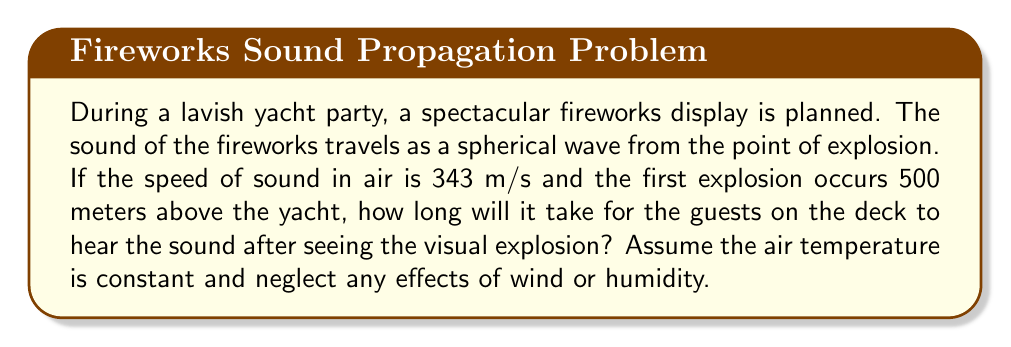What is the answer to this math problem? To solve this problem, we'll use the wave equation in its simplest form for a uniform medium:

$$\frac{\partial^2 u}{\partial t^2} = c^2 \nabla^2 u$$

Where $c$ is the speed of sound in air.

For our case, we're interested in the time it takes for the sound to travel a certain distance. We can use the relationship:

$$\text{Distance} = \text{Speed} \times \text{Time}$$

Or in equation form:
$$d = ct$$

Where:
$d$ = distance traveled by the sound wave
$c$ = speed of sound in air
$t$ = time taken

We're given:
$c = 343$ m/s
$d = 500$ m (straight-line distance from explosion to yacht)

Rearranging the equation to solve for time:

$$t = \frac{d}{c}$$

Substituting our values:

$$t = \frac{500 \text{ m}}{343 \text{ m/s}}$$

$$t \approx 1.4577 \text{ seconds}$$

Therefore, the guests will hear the sound of the fireworks approximately 1.46 seconds after seeing the visual explosion.
Answer: 1.46 seconds 